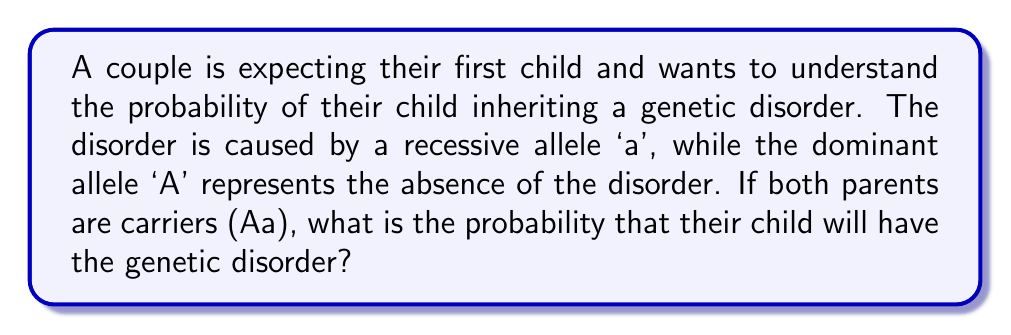Provide a solution to this math problem. To solve this problem, we'll use a Punnett square:

1. Set up the Punnett square:
   $$
   \begin{array}{c|c|c}
    & A & a \\
   \hline
   A & AA & Aa \\
   \hline
   a & Aa & aa \\
   \end{array}
   $$

2. Identify the genotypes:
   - AA: Homozygous dominant (no disorder)
   - Aa: Heterozygous (carrier, no disorder)
   - aa: Homozygous recessive (has the disorder)

3. Count the outcomes:
   - Total outcomes: 4
   - Outcomes with the disorder (aa): 1

4. Calculate the probability:
   $$P(\text{child has disorder}) = \frac{\text{favorable outcomes}}{\text{total outcomes}} = \frac{1}{4} = 0.25 = 25\%$$
Answer: $\frac{1}{4}$ or $25\%$ 